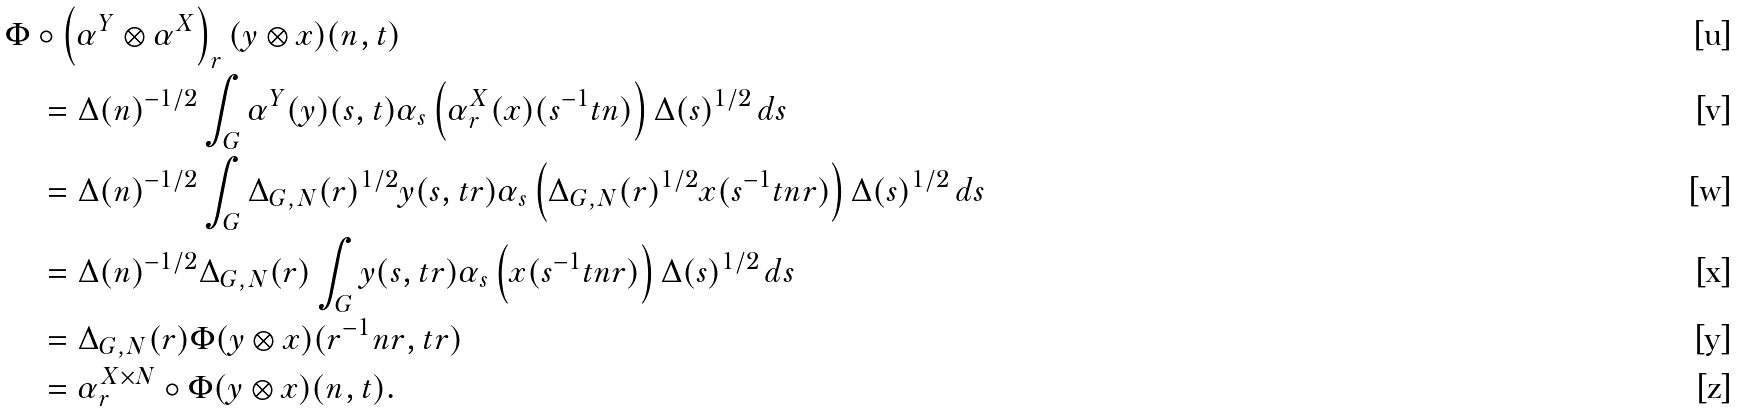Convert formula to latex. <formula><loc_0><loc_0><loc_500><loc_500>& \Phi \circ \left ( \alpha ^ { Y } \otimes \alpha ^ { X } \right ) _ { r } ( y \otimes x ) ( n , t ) \\ & \quad = \Delta ( n ) ^ { - 1 / 2 } \int _ { G } \alpha ^ { Y } ( y ) ( s , t ) \alpha _ { s } \left ( \alpha ^ { X } _ { r } ( x ) ( s ^ { - 1 } t n ) \right ) \Delta ( s ) ^ { 1 / 2 } \, d s \\ & \quad = \Delta ( n ) ^ { - 1 / 2 } \int _ { G } \Delta _ { G , N } ( r ) ^ { 1 / 2 } y ( s , t r ) \alpha _ { s } \left ( \Delta _ { G , N } ( r ) ^ { 1 / 2 } x ( s ^ { - 1 } t n r ) \right ) \Delta ( s ) ^ { 1 / 2 } \, d s \\ & \quad = \Delta ( n ) ^ { - 1 / 2 } \Delta _ { G , N } ( r ) \int _ { G } y ( s , t r ) \alpha _ { s } \left ( x ( s ^ { - 1 } t n r ) \right ) \Delta ( s ) ^ { 1 / 2 } \, d s \\ & \quad = \Delta _ { G , N } ( r ) \Phi ( y \otimes x ) ( r ^ { - 1 } n r , t r ) \\ & \quad = \alpha ^ { X \times N } _ { r } \circ \Phi ( y \otimes x ) ( n , t ) .</formula> 